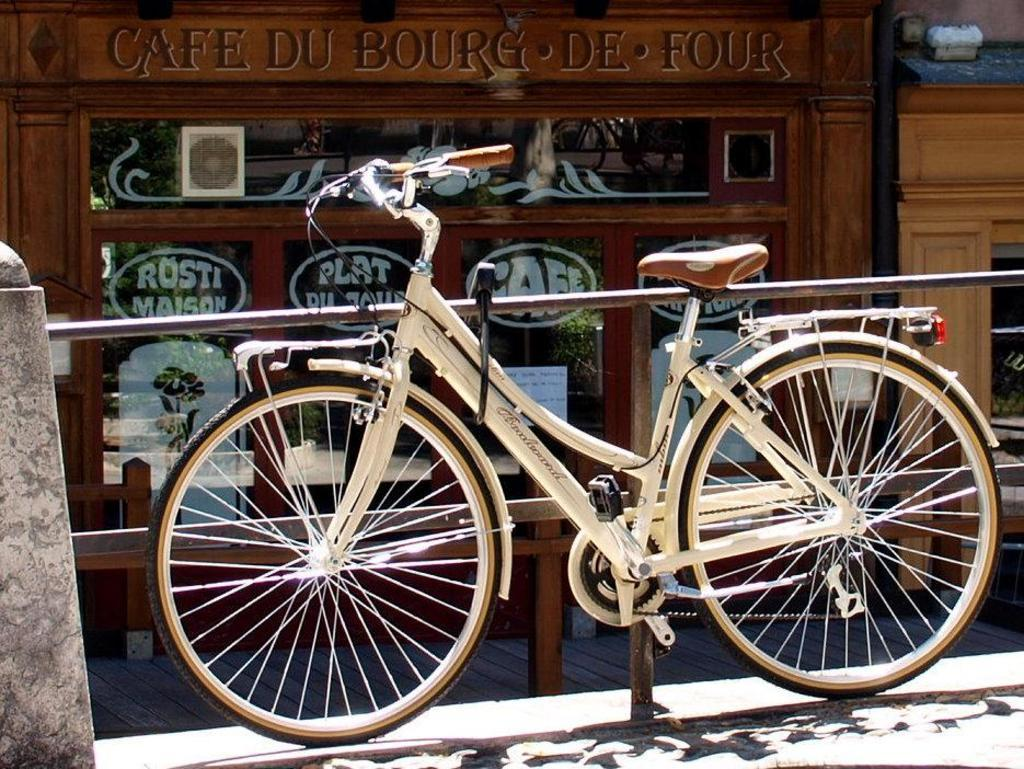What type of vehicle is in the image? There is a white color cycle in the image. Where is the cycle located? The cycle is parked on the footpath. What is behind the cycle? There is a pipe railing behind the cycle. What can be seen in the background of the image? There is a shop made with wood and glass in the background of the image. Can you tell me how many dolls are sitting on the cycle in the image? There are no dolls present in the image; it features a white color cycle parked on the footpath. What type of vacation is being taken by the porter in the image? There is no porter or vacation depicted in the image; it shows a parked cycle and a shop in the background. 